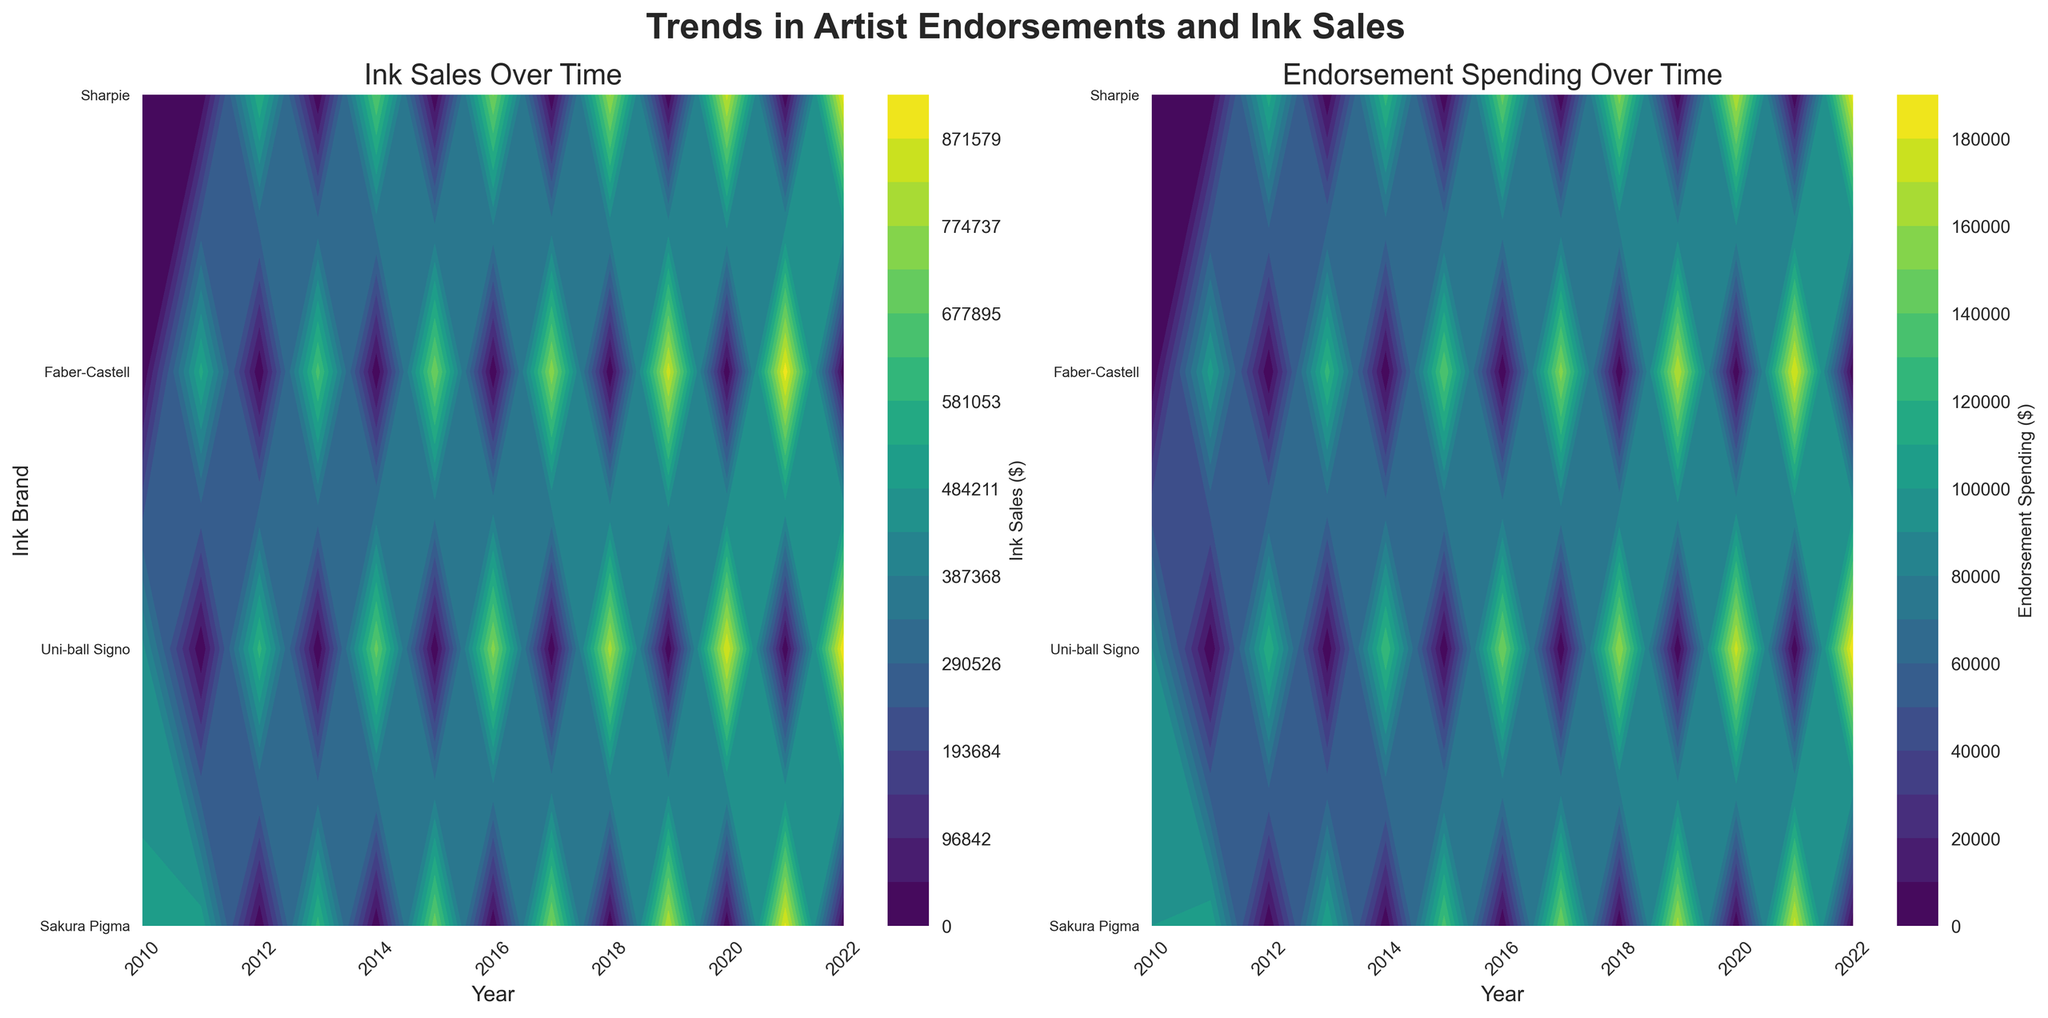What are the titles of the two subplots? The titles of the subplots can be found at the top of each plot. The left plot is titled "Ink Sales Over Time," and the right plot is titled "Endorsement Spending Over Time."
Answer: "Ink Sales Over Time" and "Endorsement Spending Over Time" Which ink brand had the highest ink sales in 2020? To find the highest ink sales for 2020, locate the year 2020 on the x-axis of the left subplot and compare the ink sales values for each brand. Uni-ball Signo had the highest sales in 2020.
Answer: Uni-ball Signo Which year shows the peak endorsement spending for Sakura Pigma? On the right subplot titled "Endorsement Spending Over Time," trace the contour lines for the brand Sakura Pigma. The peak happens in 2021, as shown by the highest contour value for that brand in that year.
Answer: 2021 How do ink sales differ between Faber-Castell and Sharpie in 2018? Compare the contour values for Faber-Castell and Sharpie in 2018 on the left subplot. Faber-Castell appears to have higher ink sales than Sharpie in that year.
Answer: Faber-Castell has higher sales than Sharpie What trend can be observed in the endorsement spending for Uni-ball Signo from 2010 to 2022? Track the contour lines for Uni-ball Signo on the right subplot from 2010 to 2022. The endorsement spending shows a consistent upward trend, indicating increasing investment over that period.
Answer: Increasing trend over time Which artist had the highest associated ink sales in 2012, and which brand were they endorsing? To find the artist with the highest ink sales in 2012, look at the highest contour value for 2012 on the left subplot and match it with the brand. The highest ink sales in 2012 were associated with Frida Kahlo, who endorsed Uni-ball Signo.
Answer: Frida Kahlo, Uni-ball Signo Between 2016 and 2020, how did the endorsement spending for Faber-Castell change? Observe the contour lines for Faber-Castell in the right subplot from 2016 to 2020. The endorsement spending shows an increasing trend over these years.
Answer: Increasing trend In which year did the endorsement for Sharpie result in the highest ink sales, according to the left subplot? On the left subplot, trace the highest contour value for Sharpie across the years. The peak ink sales for Sharpie occur in 2020.
Answer: 2020 Is there any ink brand with relatively stable ink sales over the years according to the left subplot? Examine the contour lines across the years for each ink brand on the left subplot. Sakura Pigma appears to have relatively stable ink sales, without dramatic peaks or valleys over the years.
Answer: Sakura Pigma What is the relationship between endorsement spending and ink sales for Uni-ball Signo? Compare the two subplots for Uni-ball Signo. Note that both the ink sales and endorsement spending show a noticeable increasing trend over the years, suggesting that higher endorsement spending correlates with higher ink sales.
Answer: Positive correlation 